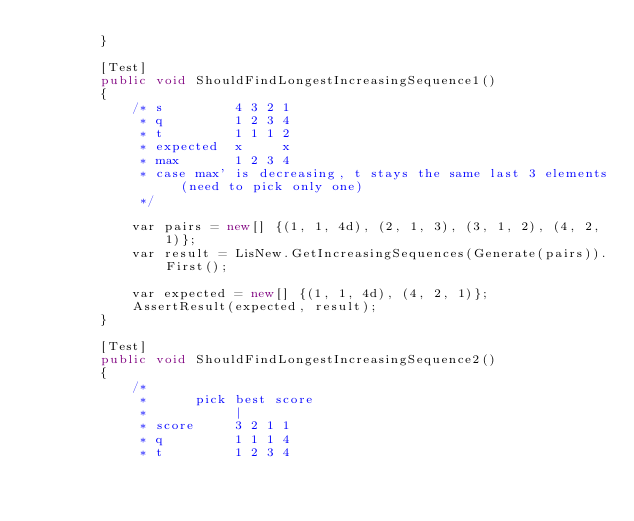<code> <loc_0><loc_0><loc_500><loc_500><_C#_>        }

        [Test]
        public void ShouldFindLongestIncreasingSequence1()
        {
            /* s         4 3 2 1
             * q         1 2 3 4
             * t         1 1 1 2
             * expected  x     x
             * max       1 2 3 4
             * case max' is decreasing, t stays the same last 3 elements (need to pick only one)
             */

            var pairs = new[] {(1, 1, 4d), (2, 1, 3), (3, 1, 2), (4, 2, 1)};
            var result = LisNew.GetIncreasingSequences(Generate(pairs)).First();

            var expected = new[] {(1, 1, 4d), (4, 2, 1)};
            AssertResult(expected, result);
        }

        [Test]
        public void ShouldFindLongestIncreasingSequence2()
        {
            /*
             *      pick best score
             *           |
             * score     3 2 1 1
             * q         1 1 1 4
             * t         1 2 3 4</code> 